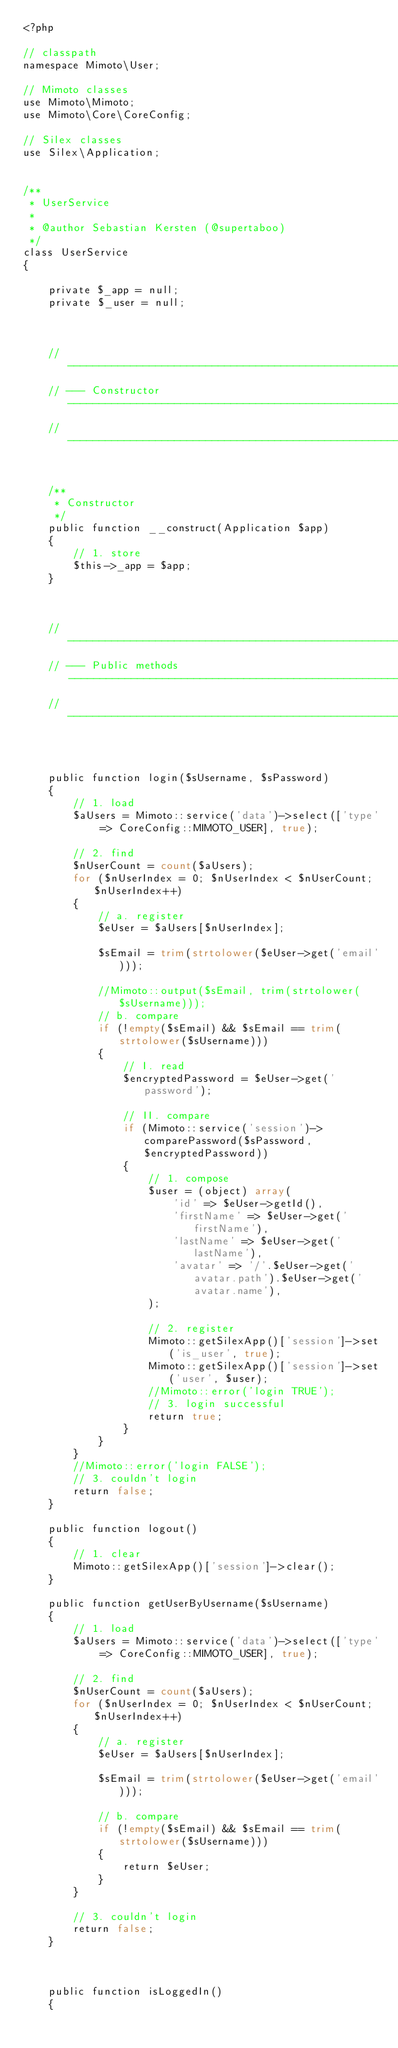<code> <loc_0><loc_0><loc_500><loc_500><_PHP_><?php

// classpath
namespace Mimoto\User;

// Mimoto classes
use Mimoto\Mimoto;
use Mimoto\Core\CoreConfig;

// Silex classes
use Silex\Application;


/**
 * UserService
 *
 * @author Sebastian Kersten (@supertaboo)
 */
class UserService
{

    private $_app = null;
    private $_user = null;



    // ----------------------------------------------------------------------------
    // --- Constructor ------------------------------------------------------------
    // ----------------------------------------------------------------------------


    /**
     * Constructor
     */
    public function __construct(Application $app)
    {
        // 1. store
        $this->_app = $app;
    }



    // ----------------------------------------------------------------------------
    // --- Public methods----------------------------------------------------------
    // ----------------------------------------------------------------------------



    public function login($sUsername, $sPassword)
    {
        // 1. load
        $aUsers = Mimoto::service('data')->select(['type' => CoreConfig::MIMOTO_USER], true);

        // 2. find
        $nUserCount = count($aUsers);
        for ($nUserIndex = 0; $nUserIndex < $nUserCount; $nUserIndex++)
        {
            // a. register
            $eUser = $aUsers[$nUserIndex];

            $sEmail = trim(strtolower($eUser->get('email')));

            //Mimoto::output($sEmail, trim(strtolower($sUsername)));
            // b. compare
            if (!empty($sEmail) && $sEmail == trim(strtolower($sUsername)))
            {
                // I. read
                $encryptedPassword = $eUser->get('password');

                // II. compare
                if (Mimoto::service('session')->comparePassword($sPassword, $encryptedPassword))
                {
                    // 1. compose
                    $user = (object) array(
                        'id' => $eUser->getId(),
                        'firstName' => $eUser->get('firstName'),
                        'lastName' => $eUser->get('lastName'),
                        'avatar' => '/'.$eUser->get('avatar.path').$eUser->get('avatar.name'),
                    );

                    // 2. register
                    Mimoto::getSilexApp()['session']->set('is_user', true);
                    Mimoto::getSilexApp()['session']->set('user', $user);
                    //Mimoto::error('login TRUE');
                    // 3. login successful
                    return true;
                }
            }
        }
        //Mimoto::error('login FALSE');
        // 3. couldn't login
        return false;
    }

    public function logout()
    {
        // 1. clear
        Mimoto::getSilexApp()['session']->clear();
    }

    public function getUserByUsername($sUsername)
    {
        // 1. load
        $aUsers = Mimoto::service('data')->select(['type' => CoreConfig::MIMOTO_USER], true);

        // 2. find
        $nUserCount = count($aUsers);
        for ($nUserIndex = 0; $nUserIndex < $nUserCount; $nUserIndex++)
        {
            // a. register
            $eUser = $aUsers[$nUserIndex];

            $sEmail = trim(strtolower($eUser->get('email')));

            // b. compare
            if (!empty($sEmail) && $sEmail == trim(strtolower($sUsername)))
            {
                return $eUser;
            }
        }

        // 3. couldn't login
        return false;
    }



    public function isLoggedIn()
    {</code> 